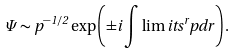<formula> <loc_0><loc_0><loc_500><loc_500>\Psi \sim p ^ { - 1 / 2 } \exp \left ( \pm i \int \lim i t s ^ { r } p d r \right ) .</formula> 